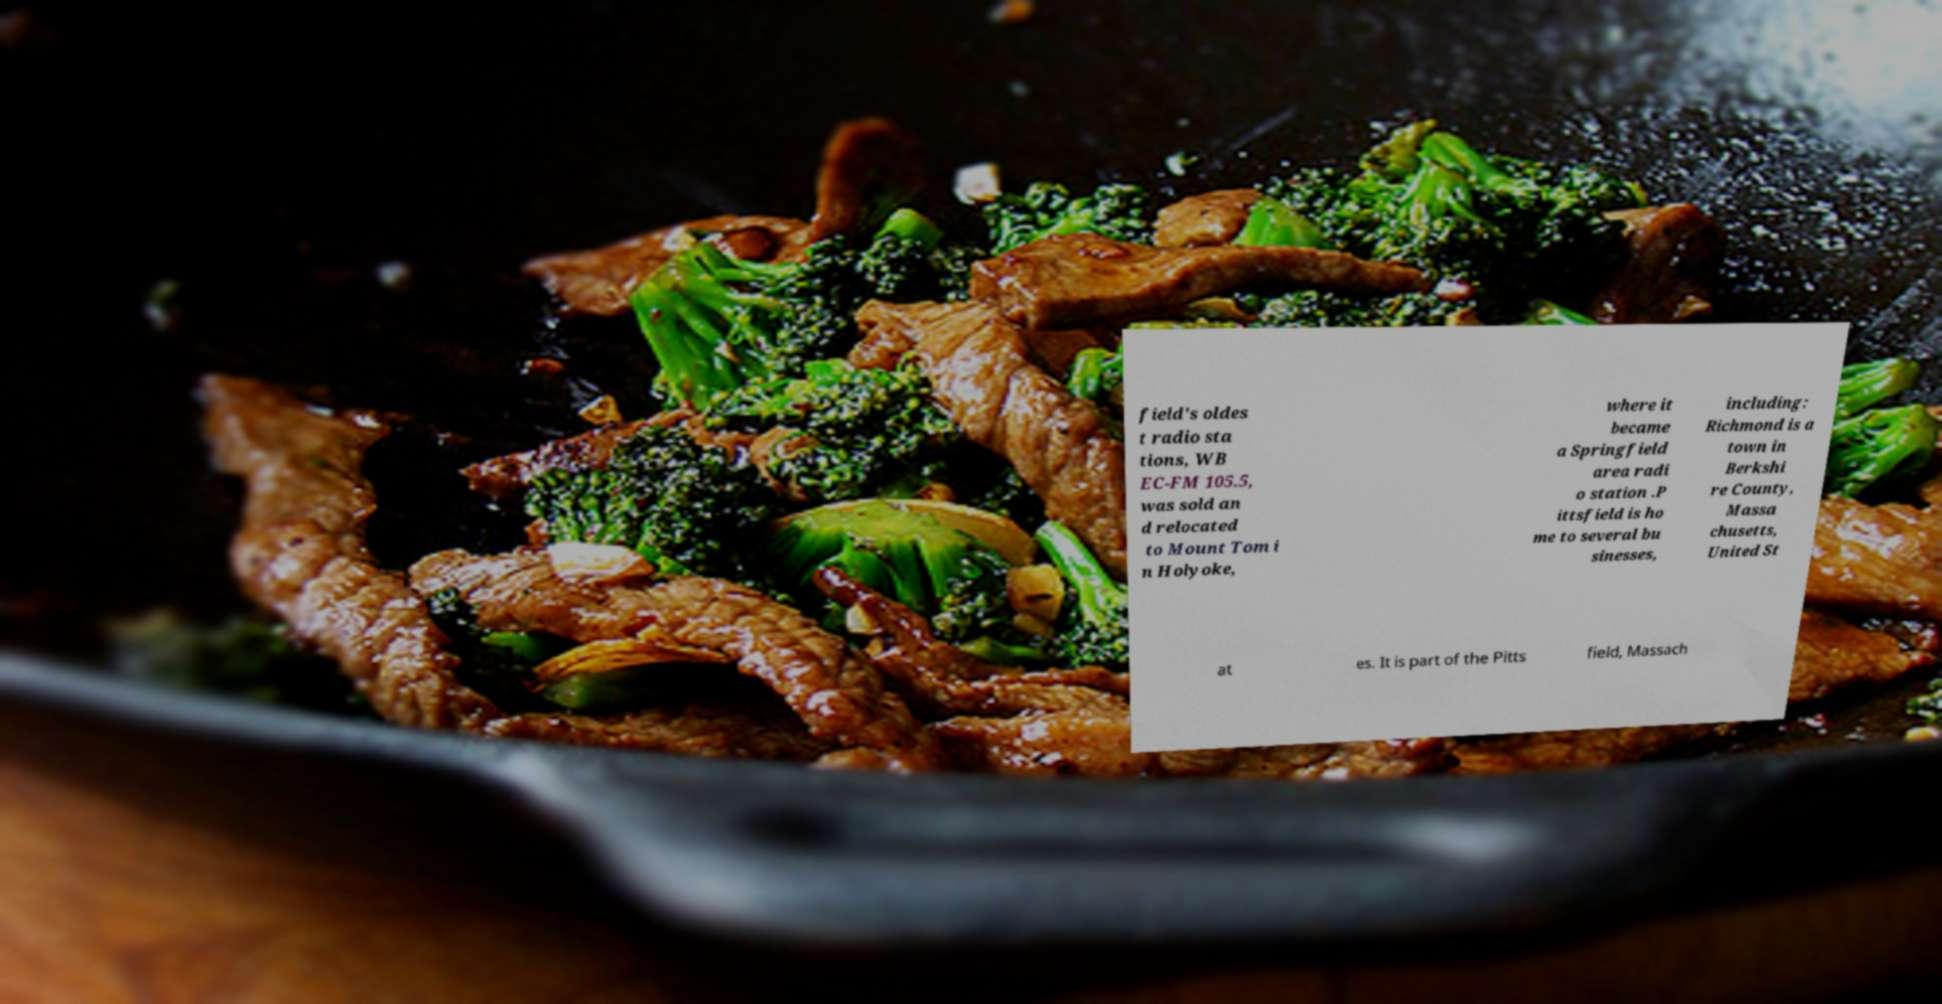For documentation purposes, I need the text within this image transcribed. Could you provide that? field's oldes t radio sta tions, WB EC-FM 105.5, was sold an d relocated to Mount Tom i n Holyoke, where it became a Springfield area radi o station .P ittsfield is ho me to several bu sinesses, including: Richmond is a town in Berkshi re County, Massa chusetts, United St at es. It is part of the Pitts field, Massach 